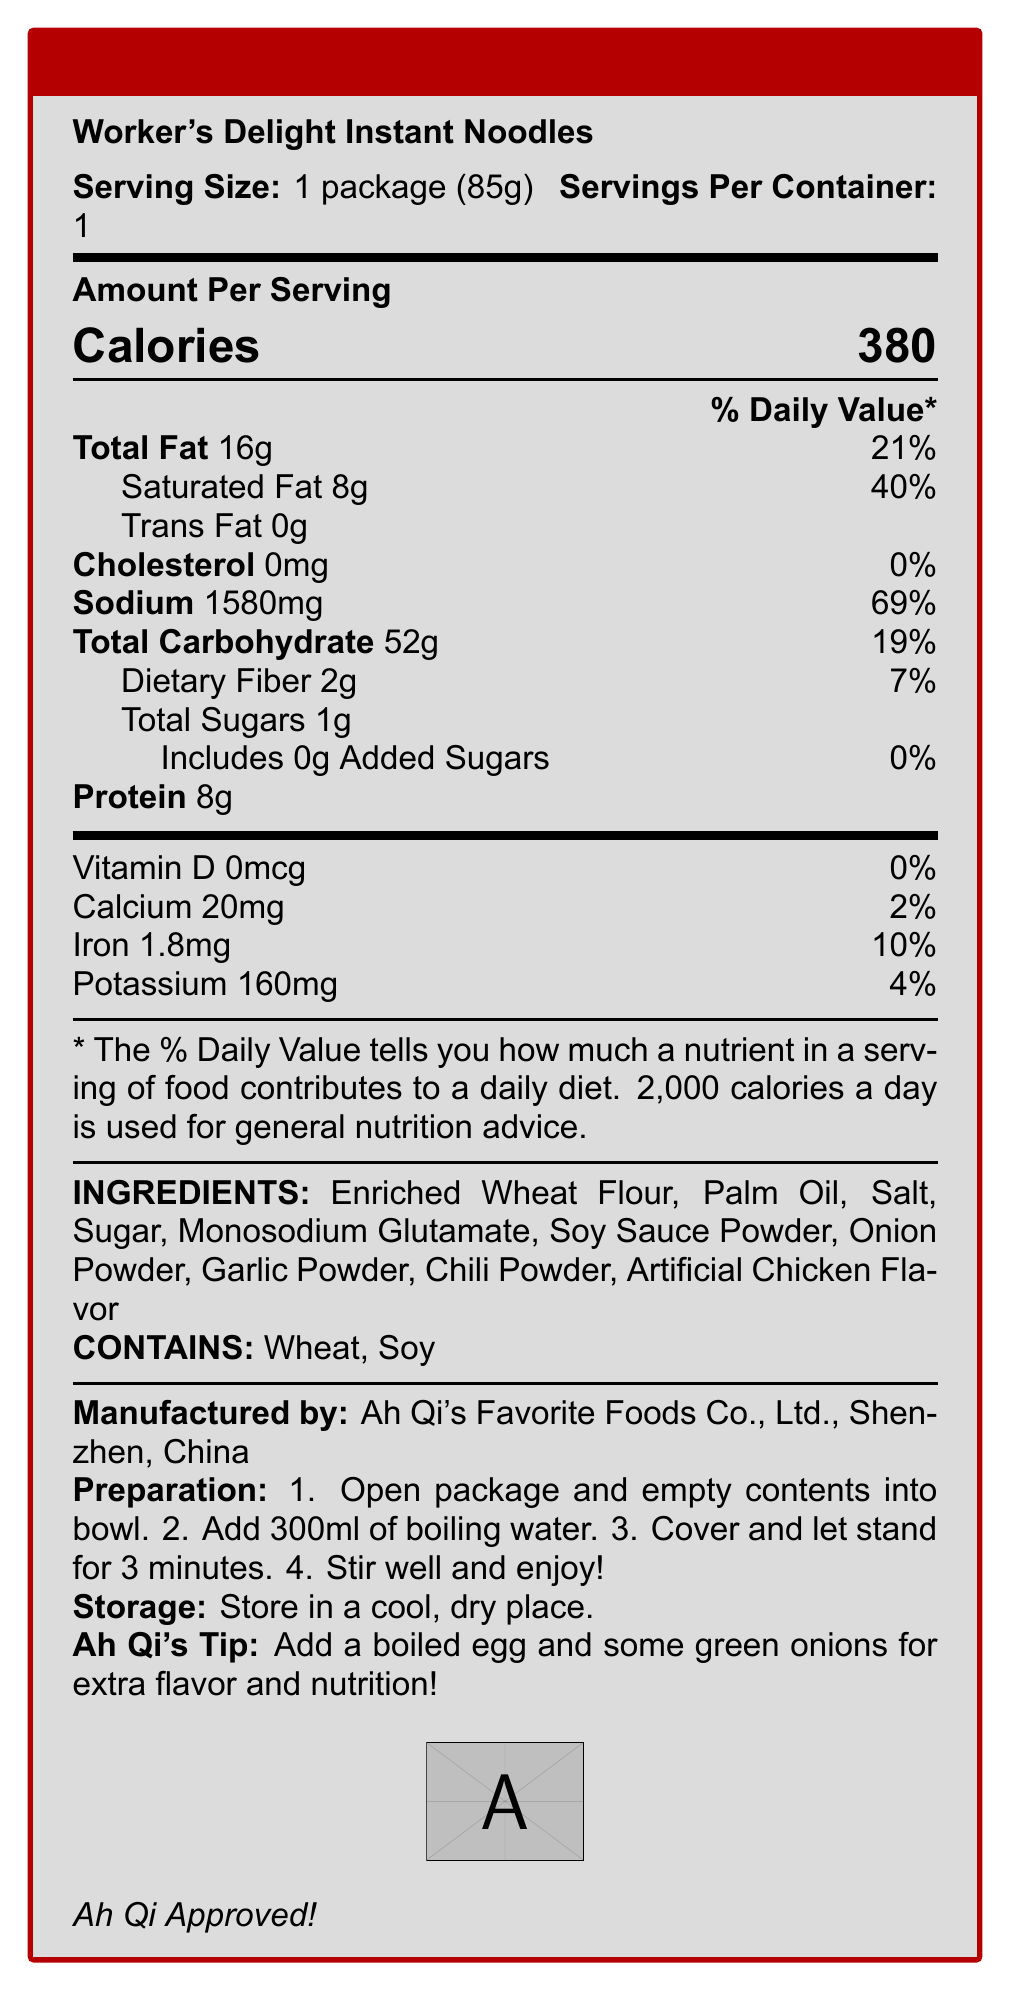how many calories are in one serving? The document states that one serving contains 380 calories.
Answer: 380 what is the serving size of Worker's Delight Instant Noodles? The document specifies that the serving size is one package, which is 85 grams.
Answer: 1 package (85g) how much sodium does one serving contain? According to the document, one serving contains 1580mg of sodium.
Answer: 1580mg what percentage of the daily value is the saturated fat content? The saturated fat content is listed as 8g, which is 40% of the daily value.
Answer: 40% what are the main ingredients in the noodles? The ingredients section lists these as the main ingredients.
Answer: Enriched Wheat Flour, Palm Oil, Salt, Sugar, Monosodium Glutamate, Soy Sauce Powder, Onion Powder, Garlic Powder, Chili Powder, Artificial Chicken Flavor which of the following allergens are present in the noodles? A. Peanuts B. Wheat C. Dairy D. Eggs The document states that the product contains wheat and soy, but it doesn't mention peanuts, dairy, or eggs.
Answer: B what is the recommended preparation method? A. Microwave for 5 minutes B. Boil the noodles for 5 minutes C. Add boiling water and let it stand for 3 minutes D. Stir-fry with vegetables The preparation instructions suggest adding boiling water and letting it stand for 3 minutes.
Answer: C is there any cholesterol in the noodles? The document specifies that the cholesterol content is 0mg, which is 0% of the daily value.
Answer: No describe the main idea of the document. This explanation summarizes the entire document content, including nutritional data and other relevant information.
Answer: This document provides the nutrition facts, ingredients, allergen information, preparation instructions, and storage guidelines for Worker's Delight Instant Noodles. Additionally, it includes a tip from Ah Qi about enhancing the noodles. is there any information on vitamin C content? The document does not mention vitamin C content.
Answer: Not enough information what is the manufacturing location for Worker's Delight Instant Noodles? The manufacturing location is specified as Shenzhen, China.
Answer: Shenzhen, China what is the daily value percentage for total fat? The document indicates that the total fat content is 16g, which is 21% of the daily value.
Answer: 21% how much protein is in one serving? The protein content per serving is listed as 8g.
Answer: 8g which company manufactures the noodles? A. Factory Foods Inc. B. Noodle Masters Co. C. Ah Qi's Favorite Foods Co., Ltd. D. Instant Noodle Corp. The document indicates that Ah Qi's Favorite Foods Co., Ltd. manufactures the noodles.
Answer: C should the instant noodles be refrigerated for storage? The document recommends storing the noodles in a cool, dry place, not in the refrigerator.
Answer: No what is Ah Qi's tip for extra flavor and nutrition? A. Add soy sauce B. Stir-fry with vegetables C. Add a boiled egg and green onions D. Top with shredded cheese Ah Qi recommends adding a boiled egg and some green onions for extra flavor and nutrition.
Answer: C 